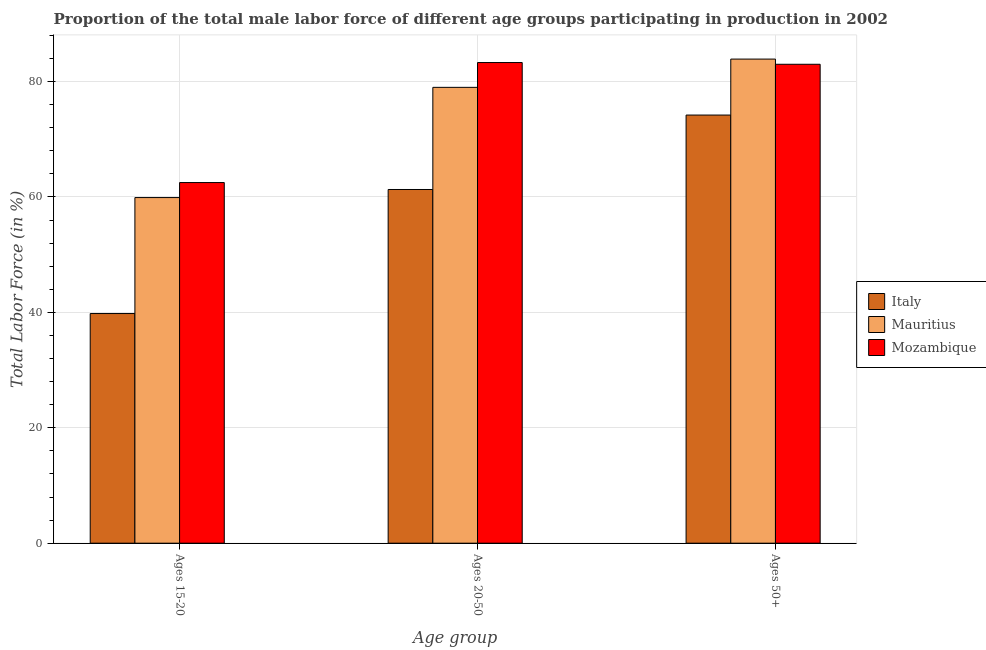How many groups of bars are there?
Keep it short and to the point. 3. What is the label of the 2nd group of bars from the left?
Provide a short and direct response. Ages 20-50. What is the percentage of male labor force within the age group 20-50 in Mozambique?
Your response must be concise. 83.3. Across all countries, what is the maximum percentage of male labor force within the age group 20-50?
Keep it short and to the point. 83.3. Across all countries, what is the minimum percentage of male labor force above age 50?
Your answer should be very brief. 74.2. In which country was the percentage of male labor force within the age group 20-50 maximum?
Give a very brief answer. Mozambique. What is the total percentage of male labor force within the age group 15-20 in the graph?
Offer a terse response. 162.2. What is the difference between the percentage of male labor force within the age group 20-50 in Mozambique and that in Italy?
Your answer should be compact. 22. What is the difference between the percentage of male labor force within the age group 15-20 in Mozambique and the percentage of male labor force within the age group 20-50 in Mauritius?
Give a very brief answer. -16.5. What is the average percentage of male labor force within the age group 15-20 per country?
Offer a very short reply. 54.07. What is the difference between the percentage of male labor force within the age group 15-20 and percentage of male labor force above age 50 in Mozambique?
Ensure brevity in your answer.  -20.5. What is the ratio of the percentage of male labor force above age 50 in Mauritius to that in Italy?
Keep it short and to the point. 1.13. What is the difference between the highest and the second highest percentage of male labor force within the age group 15-20?
Ensure brevity in your answer.  2.6. What is the difference between the highest and the lowest percentage of male labor force above age 50?
Your answer should be very brief. 9.7. Is the sum of the percentage of male labor force within the age group 20-50 in Mozambique and Italy greater than the maximum percentage of male labor force above age 50 across all countries?
Your answer should be very brief. Yes. What does the 3rd bar from the left in Ages 15-20 represents?
Provide a succinct answer. Mozambique. What does the 1st bar from the right in Ages 50+ represents?
Offer a terse response. Mozambique. Is it the case that in every country, the sum of the percentage of male labor force within the age group 15-20 and percentage of male labor force within the age group 20-50 is greater than the percentage of male labor force above age 50?
Keep it short and to the point. Yes. How many bars are there?
Your answer should be very brief. 9. Are all the bars in the graph horizontal?
Offer a terse response. No. What is the difference between two consecutive major ticks on the Y-axis?
Make the answer very short. 20. Are the values on the major ticks of Y-axis written in scientific E-notation?
Give a very brief answer. No. Does the graph contain any zero values?
Your answer should be very brief. No. Where does the legend appear in the graph?
Keep it short and to the point. Center right. How are the legend labels stacked?
Provide a short and direct response. Vertical. What is the title of the graph?
Provide a succinct answer. Proportion of the total male labor force of different age groups participating in production in 2002. Does "St. Martin (French part)" appear as one of the legend labels in the graph?
Offer a very short reply. No. What is the label or title of the X-axis?
Provide a succinct answer. Age group. What is the Total Labor Force (in %) of Italy in Ages 15-20?
Give a very brief answer. 39.8. What is the Total Labor Force (in %) in Mauritius in Ages 15-20?
Offer a very short reply. 59.9. What is the Total Labor Force (in %) of Mozambique in Ages 15-20?
Your answer should be compact. 62.5. What is the Total Labor Force (in %) in Italy in Ages 20-50?
Your answer should be very brief. 61.3. What is the Total Labor Force (in %) of Mauritius in Ages 20-50?
Make the answer very short. 79. What is the Total Labor Force (in %) of Mozambique in Ages 20-50?
Your response must be concise. 83.3. What is the Total Labor Force (in %) of Italy in Ages 50+?
Offer a terse response. 74.2. What is the Total Labor Force (in %) of Mauritius in Ages 50+?
Your response must be concise. 83.9. Across all Age group, what is the maximum Total Labor Force (in %) in Italy?
Offer a terse response. 74.2. Across all Age group, what is the maximum Total Labor Force (in %) of Mauritius?
Provide a succinct answer. 83.9. Across all Age group, what is the maximum Total Labor Force (in %) of Mozambique?
Provide a short and direct response. 83.3. Across all Age group, what is the minimum Total Labor Force (in %) in Italy?
Your answer should be very brief. 39.8. Across all Age group, what is the minimum Total Labor Force (in %) in Mauritius?
Your answer should be compact. 59.9. Across all Age group, what is the minimum Total Labor Force (in %) of Mozambique?
Your answer should be compact. 62.5. What is the total Total Labor Force (in %) in Italy in the graph?
Provide a short and direct response. 175.3. What is the total Total Labor Force (in %) of Mauritius in the graph?
Give a very brief answer. 222.8. What is the total Total Labor Force (in %) of Mozambique in the graph?
Your response must be concise. 228.8. What is the difference between the Total Labor Force (in %) in Italy in Ages 15-20 and that in Ages 20-50?
Ensure brevity in your answer.  -21.5. What is the difference between the Total Labor Force (in %) in Mauritius in Ages 15-20 and that in Ages 20-50?
Your response must be concise. -19.1. What is the difference between the Total Labor Force (in %) in Mozambique in Ages 15-20 and that in Ages 20-50?
Your answer should be very brief. -20.8. What is the difference between the Total Labor Force (in %) in Italy in Ages 15-20 and that in Ages 50+?
Your answer should be compact. -34.4. What is the difference between the Total Labor Force (in %) of Mozambique in Ages 15-20 and that in Ages 50+?
Make the answer very short. -20.5. What is the difference between the Total Labor Force (in %) in Italy in Ages 20-50 and that in Ages 50+?
Ensure brevity in your answer.  -12.9. What is the difference between the Total Labor Force (in %) in Italy in Ages 15-20 and the Total Labor Force (in %) in Mauritius in Ages 20-50?
Your response must be concise. -39.2. What is the difference between the Total Labor Force (in %) of Italy in Ages 15-20 and the Total Labor Force (in %) of Mozambique in Ages 20-50?
Give a very brief answer. -43.5. What is the difference between the Total Labor Force (in %) of Mauritius in Ages 15-20 and the Total Labor Force (in %) of Mozambique in Ages 20-50?
Provide a succinct answer. -23.4. What is the difference between the Total Labor Force (in %) in Italy in Ages 15-20 and the Total Labor Force (in %) in Mauritius in Ages 50+?
Your answer should be very brief. -44.1. What is the difference between the Total Labor Force (in %) of Italy in Ages 15-20 and the Total Labor Force (in %) of Mozambique in Ages 50+?
Keep it short and to the point. -43.2. What is the difference between the Total Labor Force (in %) in Mauritius in Ages 15-20 and the Total Labor Force (in %) in Mozambique in Ages 50+?
Offer a terse response. -23.1. What is the difference between the Total Labor Force (in %) of Italy in Ages 20-50 and the Total Labor Force (in %) of Mauritius in Ages 50+?
Ensure brevity in your answer.  -22.6. What is the difference between the Total Labor Force (in %) in Italy in Ages 20-50 and the Total Labor Force (in %) in Mozambique in Ages 50+?
Provide a succinct answer. -21.7. What is the difference between the Total Labor Force (in %) in Mauritius in Ages 20-50 and the Total Labor Force (in %) in Mozambique in Ages 50+?
Provide a short and direct response. -4. What is the average Total Labor Force (in %) of Italy per Age group?
Your answer should be compact. 58.43. What is the average Total Labor Force (in %) in Mauritius per Age group?
Your answer should be very brief. 74.27. What is the average Total Labor Force (in %) in Mozambique per Age group?
Make the answer very short. 76.27. What is the difference between the Total Labor Force (in %) of Italy and Total Labor Force (in %) of Mauritius in Ages 15-20?
Your response must be concise. -20.1. What is the difference between the Total Labor Force (in %) in Italy and Total Labor Force (in %) in Mozambique in Ages 15-20?
Your response must be concise. -22.7. What is the difference between the Total Labor Force (in %) in Italy and Total Labor Force (in %) in Mauritius in Ages 20-50?
Your response must be concise. -17.7. What is the difference between the Total Labor Force (in %) of Italy and Total Labor Force (in %) of Mozambique in Ages 20-50?
Offer a very short reply. -22. What is the difference between the Total Labor Force (in %) of Italy and Total Labor Force (in %) of Mauritius in Ages 50+?
Your answer should be very brief. -9.7. What is the difference between the Total Labor Force (in %) in Italy and Total Labor Force (in %) in Mozambique in Ages 50+?
Provide a short and direct response. -8.8. What is the ratio of the Total Labor Force (in %) of Italy in Ages 15-20 to that in Ages 20-50?
Offer a very short reply. 0.65. What is the ratio of the Total Labor Force (in %) of Mauritius in Ages 15-20 to that in Ages 20-50?
Give a very brief answer. 0.76. What is the ratio of the Total Labor Force (in %) of Mozambique in Ages 15-20 to that in Ages 20-50?
Provide a short and direct response. 0.75. What is the ratio of the Total Labor Force (in %) of Italy in Ages 15-20 to that in Ages 50+?
Provide a short and direct response. 0.54. What is the ratio of the Total Labor Force (in %) of Mauritius in Ages 15-20 to that in Ages 50+?
Your answer should be compact. 0.71. What is the ratio of the Total Labor Force (in %) in Mozambique in Ages 15-20 to that in Ages 50+?
Ensure brevity in your answer.  0.75. What is the ratio of the Total Labor Force (in %) in Italy in Ages 20-50 to that in Ages 50+?
Your response must be concise. 0.83. What is the ratio of the Total Labor Force (in %) of Mauritius in Ages 20-50 to that in Ages 50+?
Ensure brevity in your answer.  0.94. What is the ratio of the Total Labor Force (in %) of Mozambique in Ages 20-50 to that in Ages 50+?
Provide a succinct answer. 1. What is the difference between the highest and the second highest Total Labor Force (in %) in Italy?
Provide a short and direct response. 12.9. What is the difference between the highest and the second highest Total Labor Force (in %) in Mauritius?
Provide a short and direct response. 4.9. What is the difference between the highest and the second highest Total Labor Force (in %) in Mozambique?
Ensure brevity in your answer.  0.3. What is the difference between the highest and the lowest Total Labor Force (in %) of Italy?
Offer a very short reply. 34.4. What is the difference between the highest and the lowest Total Labor Force (in %) in Mauritius?
Ensure brevity in your answer.  24. What is the difference between the highest and the lowest Total Labor Force (in %) in Mozambique?
Give a very brief answer. 20.8. 